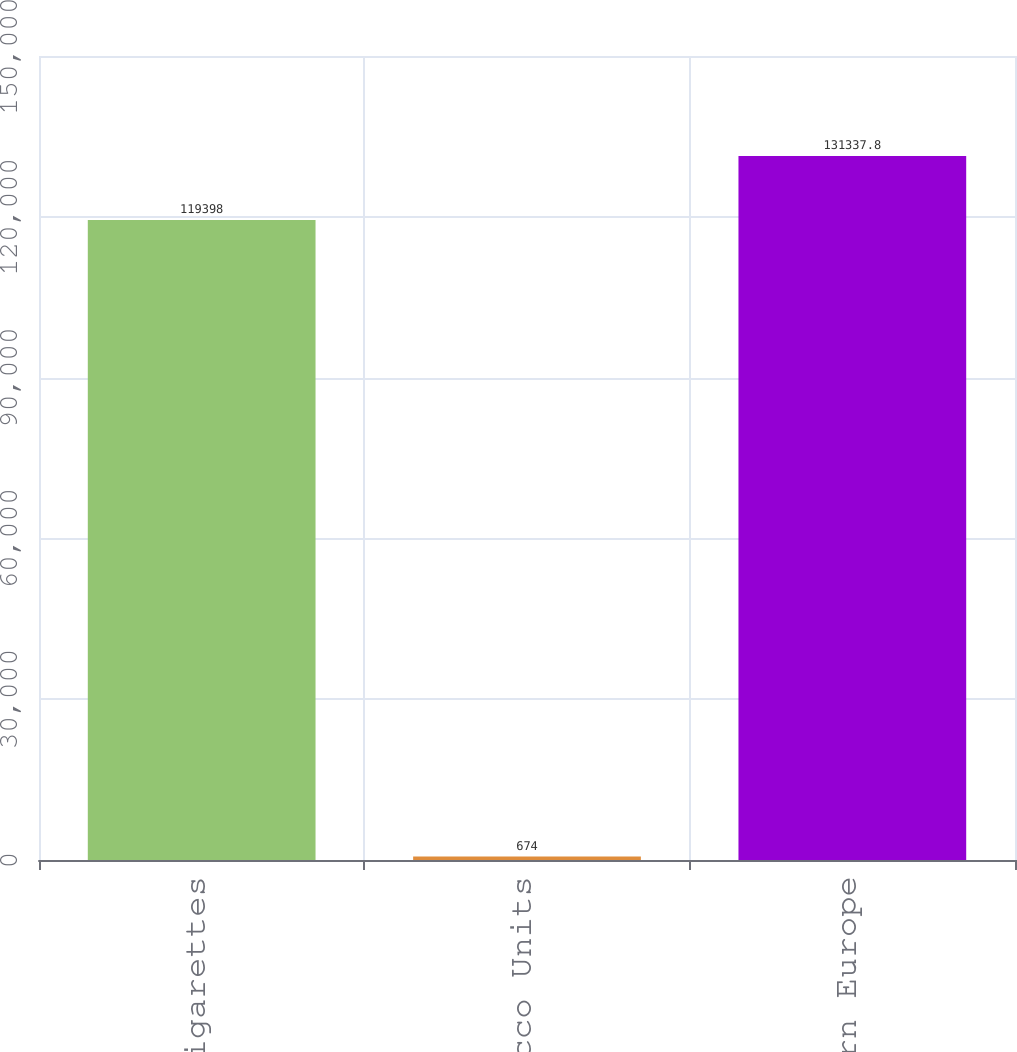Convert chart. <chart><loc_0><loc_0><loc_500><loc_500><bar_chart><fcel>Cigarettes<fcel>Heated Tobacco Units<fcel>Total Eastern Europe<nl><fcel>119398<fcel>674<fcel>131338<nl></chart> 